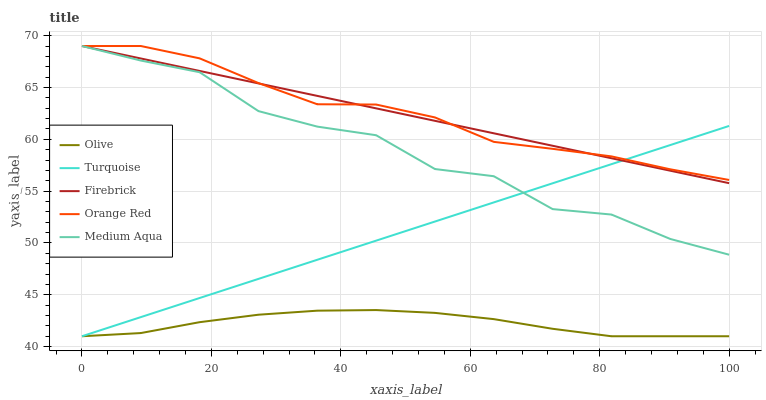Does Olive have the minimum area under the curve?
Answer yes or no. Yes. Does Orange Red have the maximum area under the curve?
Answer yes or no. Yes. Does Turquoise have the minimum area under the curve?
Answer yes or no. No. Does Turquoise have the maximum area under the curve?
Answer yes or no. No. Is Turquoise the smoothest?
Answer yes or no. Yes. Is Medium Aqua the roughest?
Answer yes or no. Yes. Is Medium Aqua the smoothest?
Answer yes or no. No. Is Turquoise the roughest?
Answer yes or no. No. Does Olive have the lowest value?
Answer yes or no. Yes. Does Medium Aqua have the lowest value?
Answer yes or no. No. Does Orange Red have the highest value?
Answer yes or no. Yes. Does Turquoise have the highest value?
Answer yes or no. No. Is Olive less than Orange Red?
Answer yes or no. Yes. Is Firebrick greater than Olive?
Answer yes or no. Yes. Does Medium Aqua intersect Turquoise?
Answer yes or no. Yes. Is Medium Aqua less than Turquoise?
Answer yes or no. No. Is Medium Aqua greater than Turquoise?
Answer yes or no. No. Does Olive intersect Orange Red?
Answer yes or no. No. 